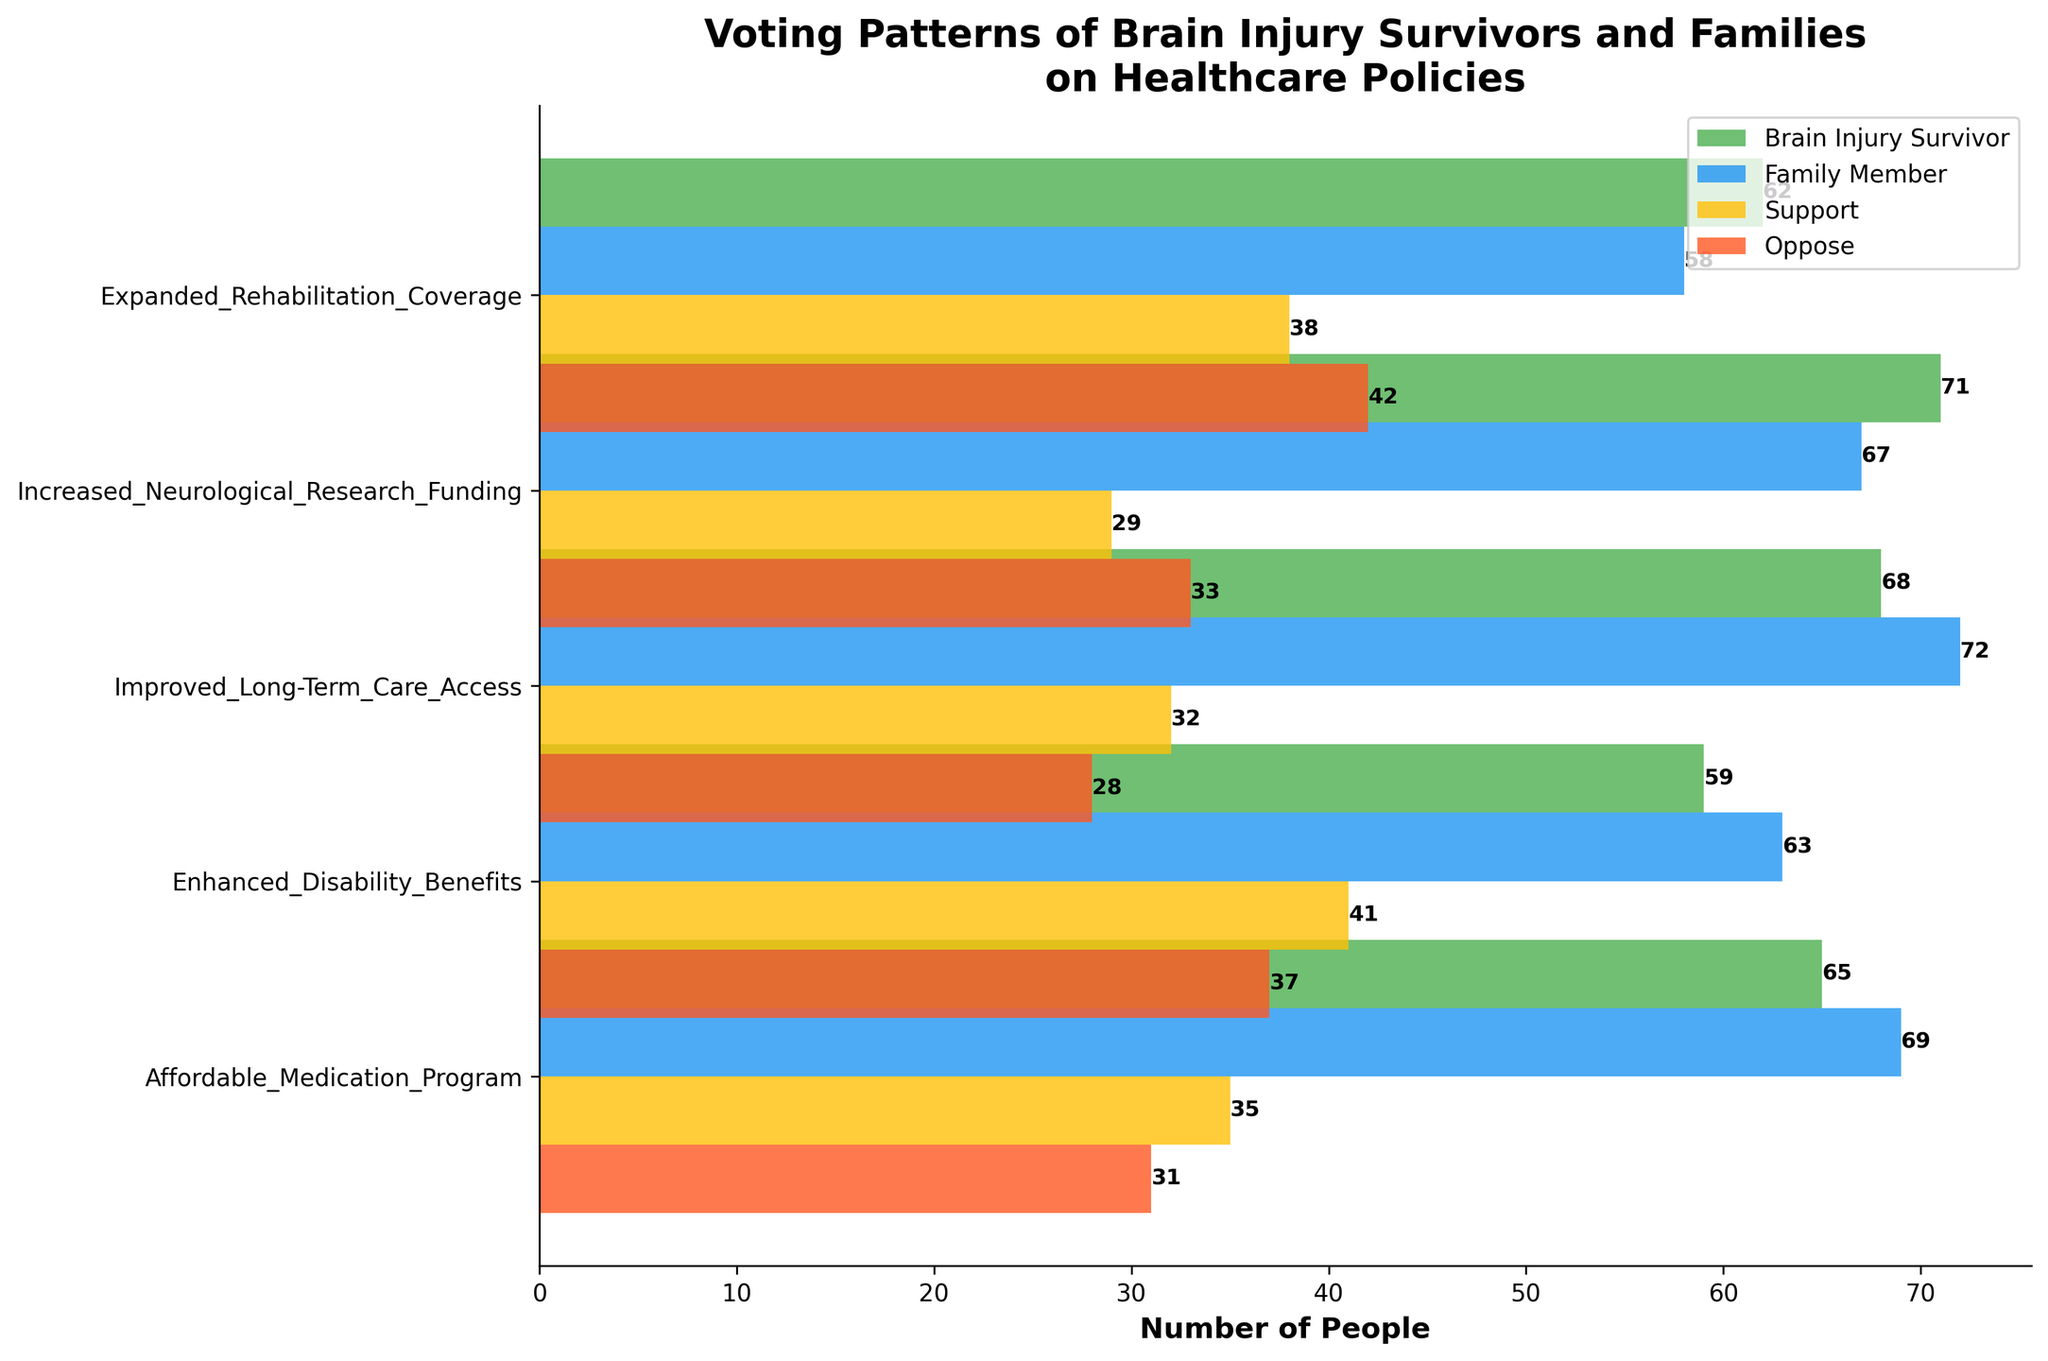What is the title of the plot? The title is located at the top center of the plot and summarizes the content visually represented.
Answer: Voting Patterns of Brain Injury Survivors and Families on Healthcare Policies How many healthcare policies are represented in the plot? Count the number of different bars along the y-axis, where each bar represents a healthcare policy.
Answer: 5 Which policy has the highest number of Brain Injury Survivors supporting it? Observe the heights of the green bars (representing Brain Injury Survivors) and identify which is tallest.
Answer: Increased Neurological Research Funding What is the total number of family members supporting Increased Neurological Research Funding and Affordable Medication Program? Refer to the blue bars for each policy, add the numbers for these two policies.
Answer: 67 + 69 = 136 How much higher is the support for Improved Long-Term Care Access among Family Members compared to Brain Injury Survivors? Subtract the number of Brain Injury Survivors supporting Improved Long-Term Care Access from the number of Family Members supporting it.
Answer: 72 - 68 = 4 Which healthcare policy has the lowest number of people opposing it? Look at the heights of the red bars for opposition and identify the shortest bar.
Answer: Improved Long-Term Care Access For the Affordable Medication Program, which group has more people opposing it, Brain Injury Survivors or Family Members? Compare the heights of the red bars for Brain Injury Survivors and Family Members within this policy.
Answer: Brain Injury Survivors What is the difference in the number of supporters for the Enhanced Disability Benefits policy between Brain Injury Survivors and their Family Members? Subtract the number of Brain Injury Survivors supporting this policy from the number of Family Members supporting it.
Answer: 63 - 59 = 4 How many people in total support the Expanded Rehabilitation Coverage policy? Add the number of Brain Injury Survivors and Family Members supporting this policy.
Answer: 62 + 58 = 120 Which group has a higher total support across all healthcare policies: Brain Injury Survivors or Family Members? Sum up all the support values for Brain Injury Survivors and Family Members, and compare the totals.
Answer: Family Members 